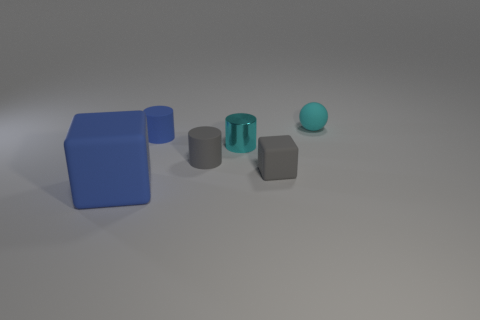Are there any other things that have the same size as the blue rubber cube?
Keep it short and to the point. No. What is the size of the rubber cube that is to the right of the small blue cylinder?
Your response must be concise. Small. What number of blocks are either cyan objects or blue matte objects?
Your answer should be compact. 1. There is a small rubber thing that is behind the blue thing that is behind the blue matte cube; what shape is it?
Provide a short and direct response. Sphere. There is a cyan thing that is in front of the tiny cylinder that is behind the cyan object that is in front of the blue rubber cylinder; what is its size?
Your answer should be very brief. Small. Does the cyan rubber sphere have the same size as the blue matte cylinder?
Give a very brief answer. Yes. How many things are cyan metallic cylinders or big rubber cylinders?
Your response must be concise. 1. How big is the cyan cylinder behind the matte object that is in front of the gray matte cube?
Provide a short and direct response. Small. The blue matte block has what size?
Offer a terse response. Large. The rubber object that is in front of the gray cylinder and on the left side of the cyan shiny cylinder has what shape?
Offer a terse response. Cube. 